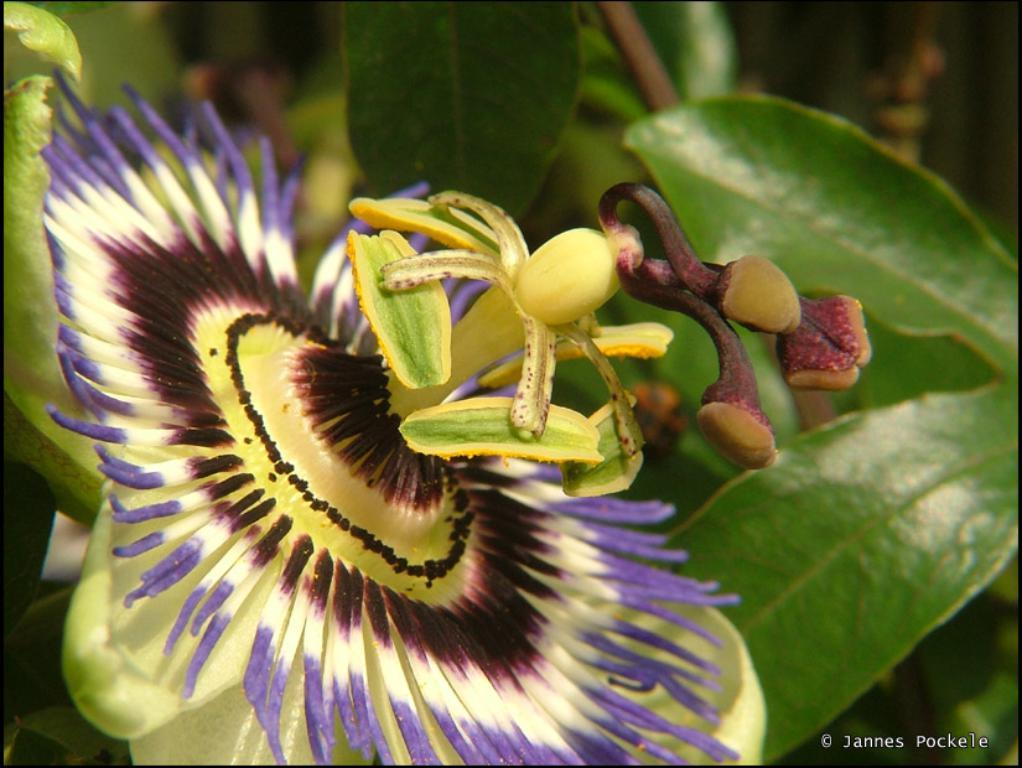What type of living organism can be seen in the image? There is a flower in the image. Are there any other similar living organisms in the image? Yes, there are plants in the image. What type of hope can be seen in the image? There is no reference to hope in the image; it features a flower and plants. 